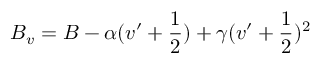Convert formula to latex. <formula><loc_0><loc_0><loc_500><loc_500>B _ { v } = B - \alpha ( v ^ { \prime } + \frac { 1 } { 2 } ) + \gamma ( v ^ { \prime } + \frac { 1 } { 2 } ) ^ { 2 }</formula> 